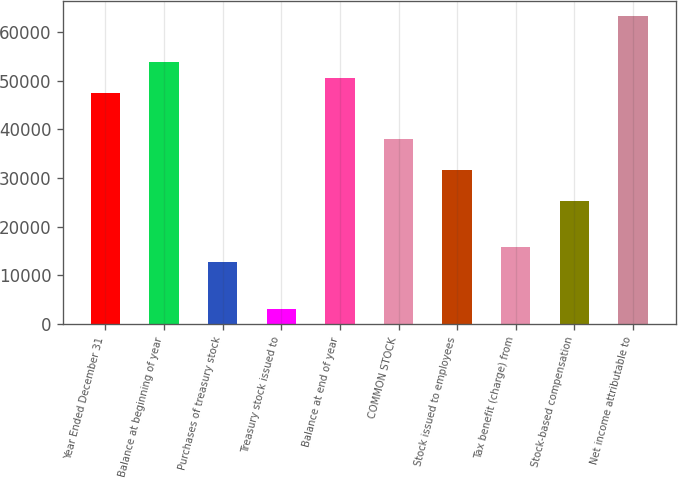<chart> <loc_0><loc_0><loc_500><loc_500><bar_chart><fcel>Year Ended December 31<fcel>Balance at beginning of year<fcel>Purchases of treasury stock<fcel>Treasury stock issued to<fcel>Balance at end of year<fcel>COMMON STOCK<fcel>Stock issued to employees<fcel>Tax benefit (charge) from<fcel>Stock-based compensation<fcel>Net income attributable to<nl><fcel>47449<fcel>53774.6<fcel>12658.2<fcel>3169.8<fcel>50611.8<fcel>37960.6<fcel>31635<fcel>15821<fcel>25309.4<fcel>63263<nl></chart> 